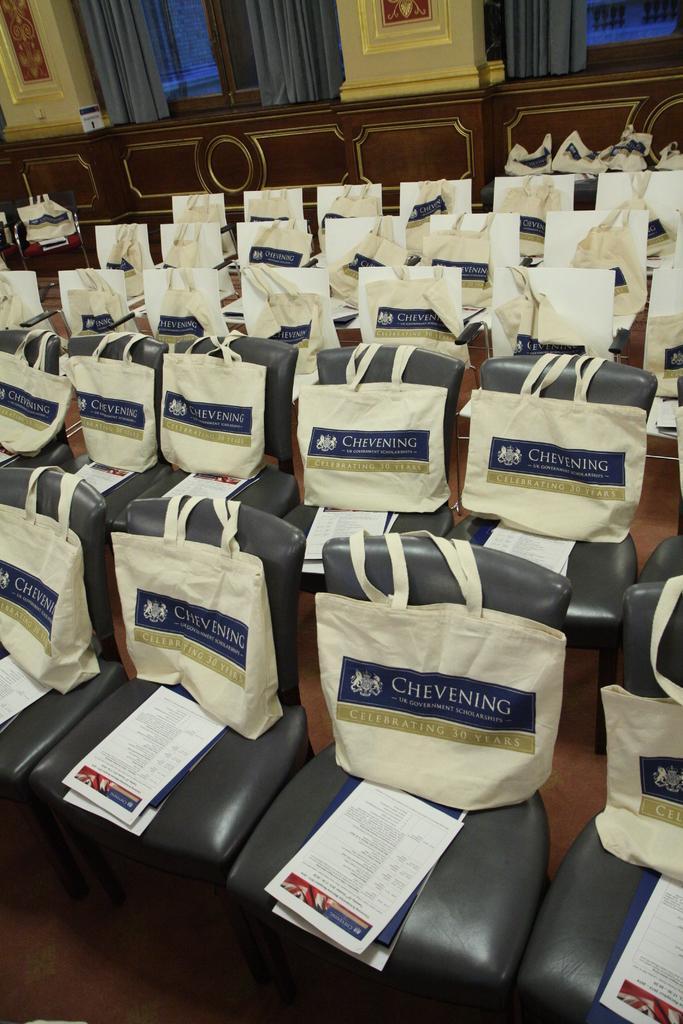Could you give a brief overview of what you see in this image? In this image there are few chairs having bags and few papers on it. Top of image there are windows to the wall. Windows are covered with curtains. 